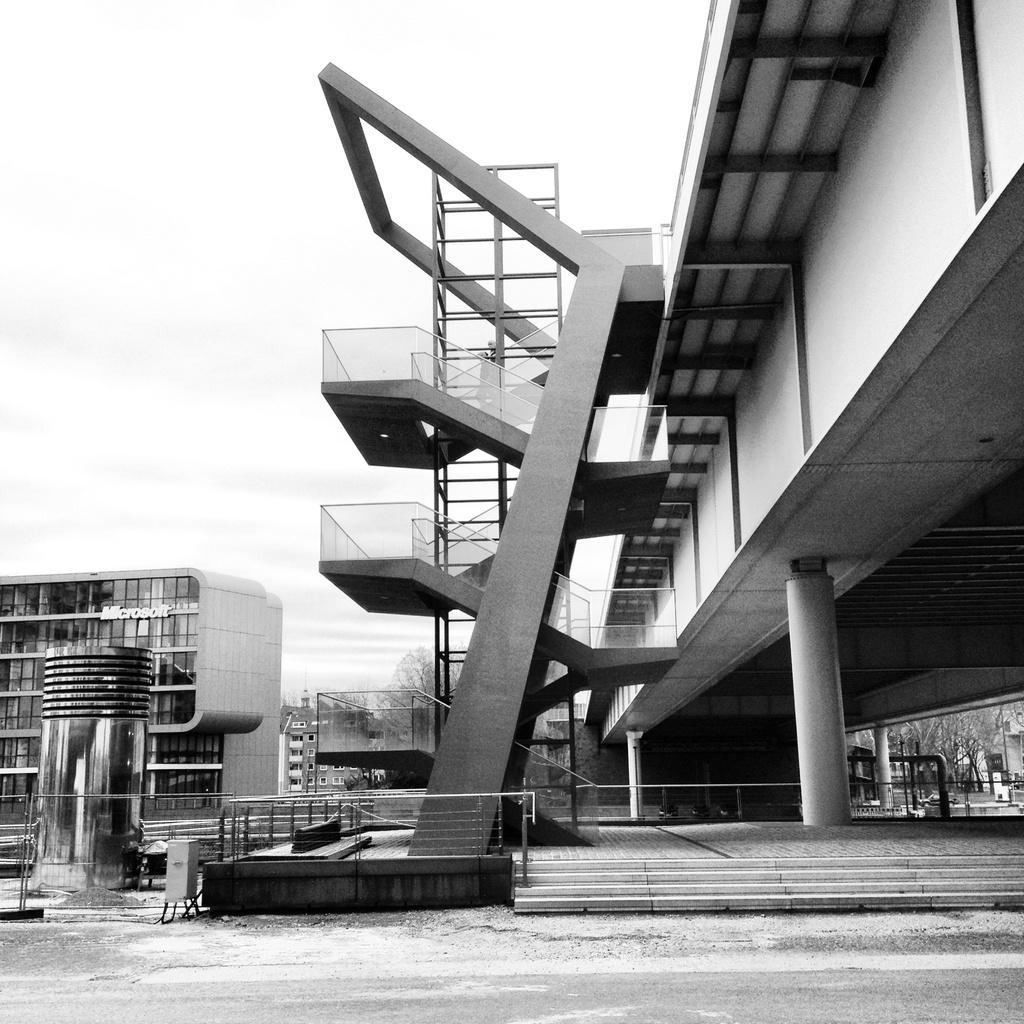Describe this image in one or two sentences. Here we can see a black and white picture. There are buildings, pillars, and trees. In the background there is sky. 